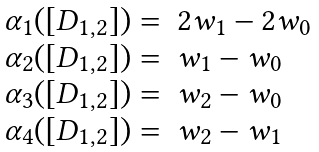<formula> <loc_0><loc_0><loc_500><loc_500>\begin{array} { l l } \alpha _ { 1 } ( [ D _ { 1 , 2 } ] ) = & 2 w _ { 1 } - 2 w _ { 0 } \\ \alpha _ { 2 } ( [ D _ { 1 , 2 } ] ) = & w _ { 1 } - w _ { 0 } \\ \alpha _ { 3 } ( [ D _ { 1 , 2 } ] ) = & w _ { 2 } - w _ { 0 } \\ \alpha _ { 4 } ( [ D _ { 1 , 2 } ] ) = & w _ { 2 } - w _ { 1 } \end{array}</formula> 